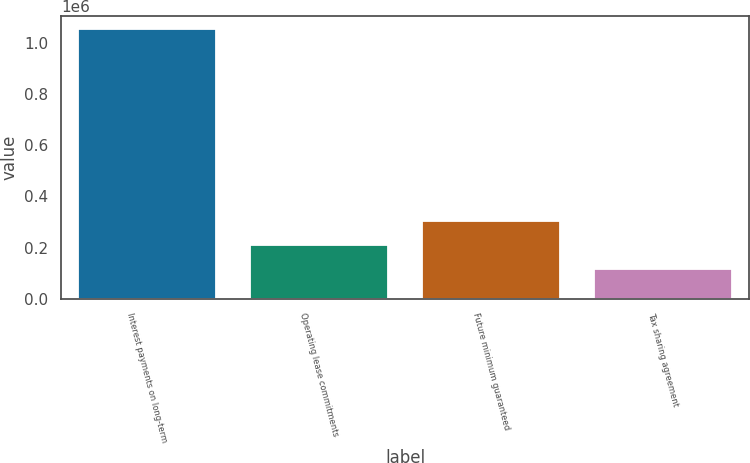<chart> <loc_0><loc_0><loc_500><loc_500><bar_chart><fcel>Interest payments on long-term<fcel>Operating lease commitments<fcel>Future minimum guaranteed<fcel>Tax sharing agreement<nl><fcel>1.05139e+06<fcel>210079<fcel>303557<fcel>116600<nl></chart> 